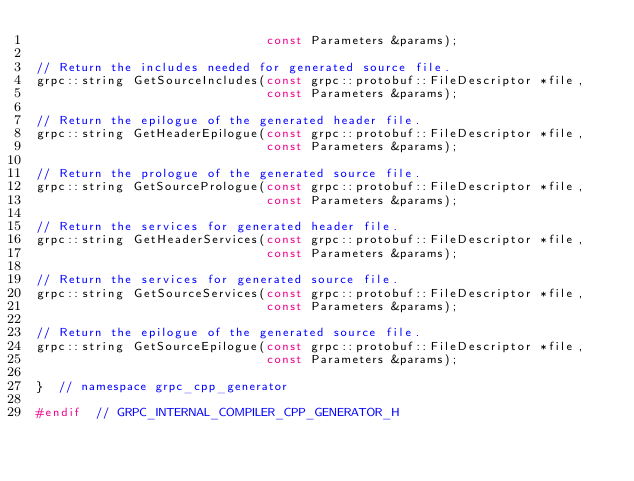Convert code to text. <code><loc_0><loc_0><loc_500><loc_500><_C_>                               const Parameters &params);

// Return the includes needed for generated source file.
grpc::string GetSourceIncludes(const grpc::protobuf::FileDescriptor *file,
                               const Parameters &params);

// Return the epilogue of the generated header file.
grpc::string GetHeaderEpilogue(const grpc::protobuf::FileDescriptor *file,
                               const Parameters &params);

// Return the prologue of the generated source file.
grpc::string GetSourcePrologue(const grpc::protobuf::FileDescriptor *file,
                               const Parameters &params);

// Return the services for generated header file.
grpc::string GetHeaderServices(const grpc::protobuf::FileDescriptor *file,
                               const Parameters &params);

// Return the services for generated source file.
grpc::string GetSourceServices(const grpc::protobuf::FileDescriptor *file,
                               const Parameters &params);

// Return the epilogue of the generated source file.
grpc::string GetSourceEpilogue(const grpc::protobuf::FileDescriptor *file,
                               const Parameters &params);

}  // namespace grpc_cpp_generator

#endif  // GRPC_INTERNAL_COMPILER_CPP_GENERATOR_H
</code> 